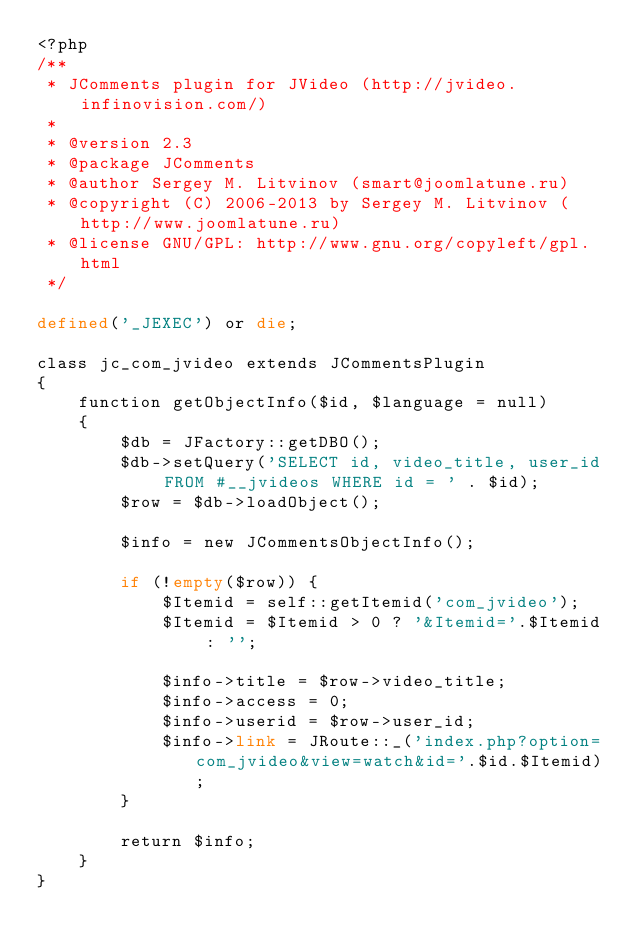<code> <loc_0><loc_0><loc_500><loc_500><_PHP_><?php
/**
 * JComments plugin for JVideo (http://jvideo.infinovision.com/)
 *
 * @version 2.3
 * @package JComments
 * @author Sergey M. Litvinov (smart@joomlatune.ru)
 * @copyright (C) 2006-2013 by Sergey M. Litvinov (http://www.joomlatune.ru)
 * @license GNU/GPL: http://www.gnu.org/copyleft/gpl.html
 */

defined('_JEXEC') or die;

class jc_com_jvideo extends JCommentsPlugin
{
	function getObjectInfo($id, $language = null)
	{
		$db = JFactory::getDBO();
		$db->setQuery('SELECT id, video_title, user_id FROM #__jvideos WHERE id = ' . $id);
		$row = $db->loadObject();

		$info = new JCommentsObjectInfo();

		if (!empty($row)) {
			$Itemid = self::getItemid('com_jvideo');
			$Itemid = $Itemid > 0 ? '&Itemid='.$Itemid : '';

			$info->title = $row->video_title;
			$info->access = 0;
			$info->userid = $row->user_id;
			$info->link = JRoute::_('index.php?option=com_jvideo&view=watch&id='.$id.$Itemid);
		}

		return $info;
	}
}</code> 